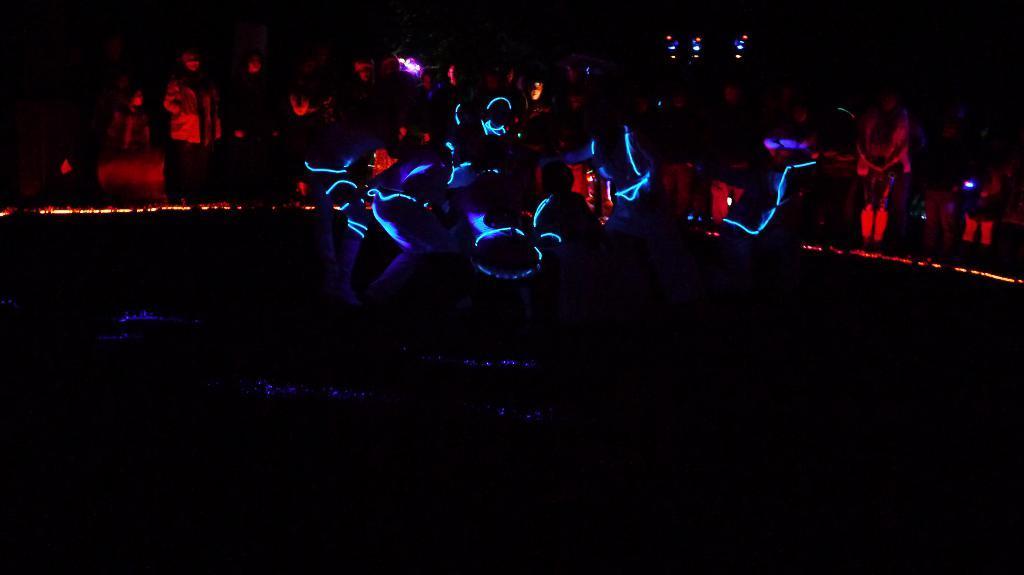Describe this image in one or two sentences. In this picture we can see a group of people, lights, some objects and in the background it is dark. 